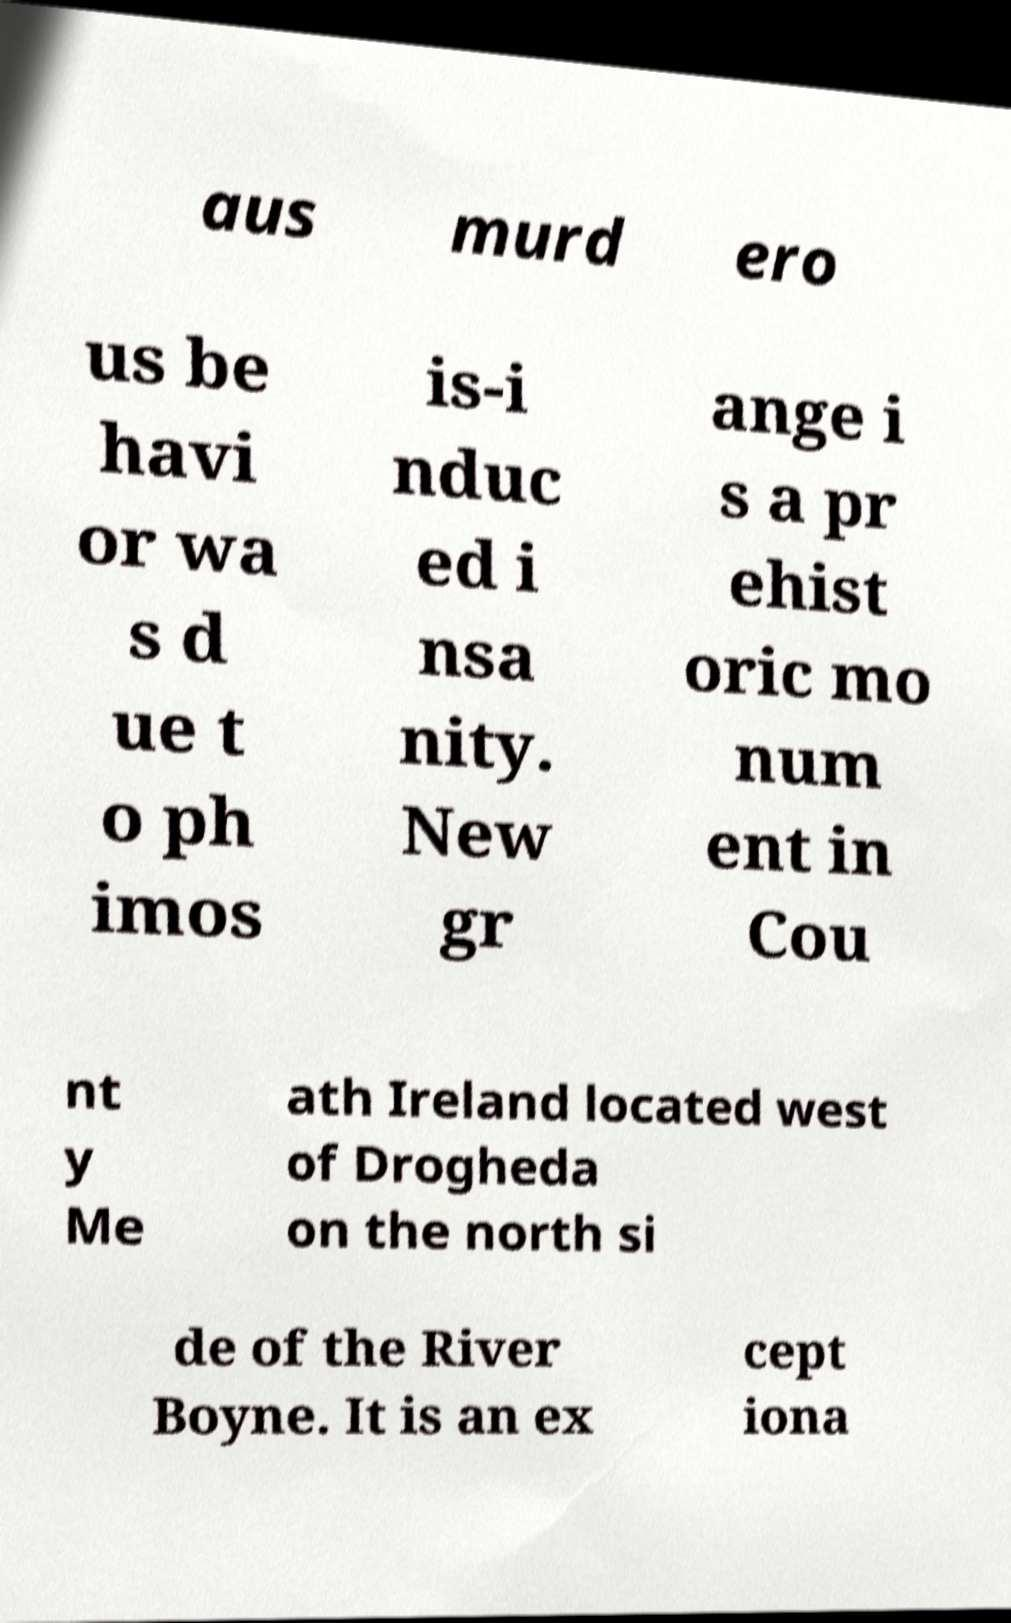Could you extract and type out the text from this image? aus murd ero us be havi or wa s d ue t o ph imos is-i nduc ed i nsa nity. New gr ange i s a pr ehist oric mo num ent in Cou nt y Me ath Ireland located west of Drogheda on the north si de of the River Boyne. It is an ex cept iona 